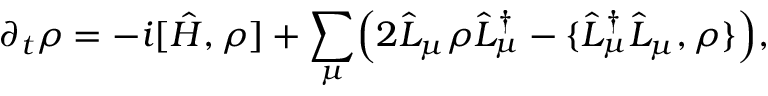Convert formula to latex. <formula><loc_0><loc_0><loc_500><loc_500>\partial _ { t } \rho = - i [ \hat { H } , \rho ] + \sum _ { \mu } \left ( 2 \hat { L } _ { \mu } \rho \hat { L } _ { \mu } ^ { \dagger } - \{ \hat { L } _ { \mu } ^ { \dagger } \hat { L } _ { \mu } , \rho \} \right ) ,</formula> 